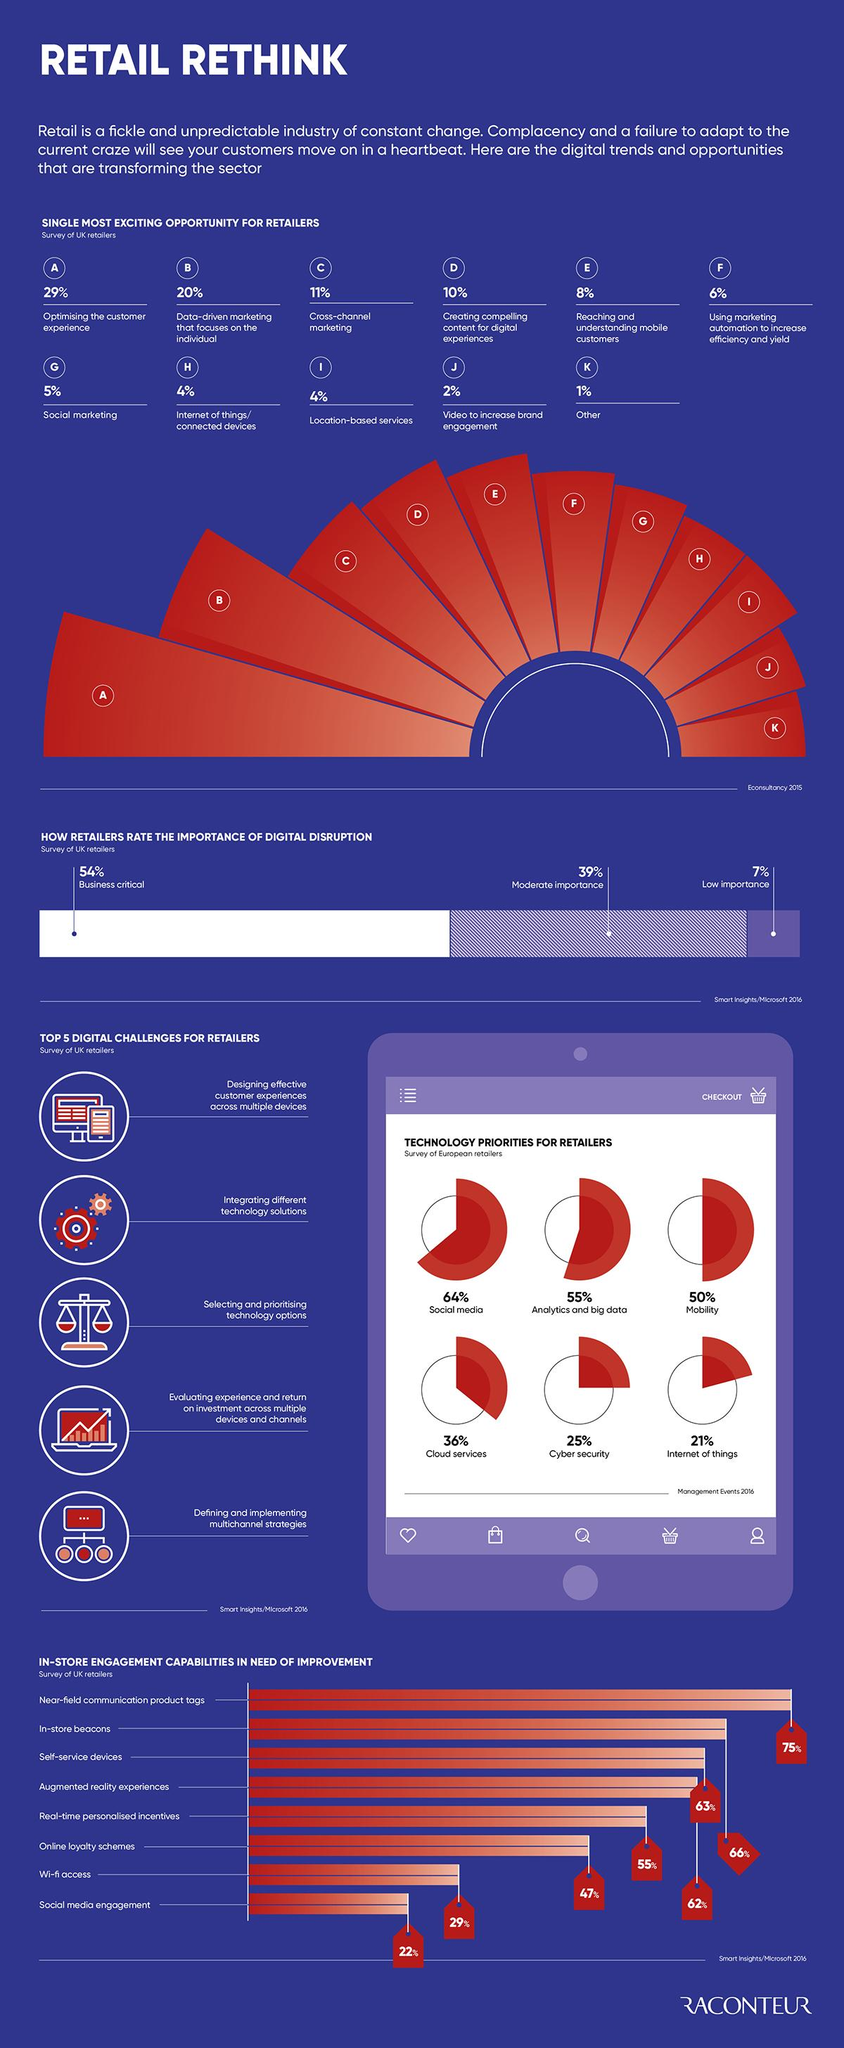Specify some key components in this picture. According to a recent survey, 22% of retailers need to improve their presence in social media in order to stay competitive in the market. According to a survey of retailers, a significant percentage, approximately 54%, believe that digital services are crucial for their business. There are 11 digital opportunities available for retailers. Cross-channel marketing has a higher percentage than Internet of things and others, according to recent data. According to the survey, a significant proportion of retailers, which is 21%, view IoT as a high priority for their business. 